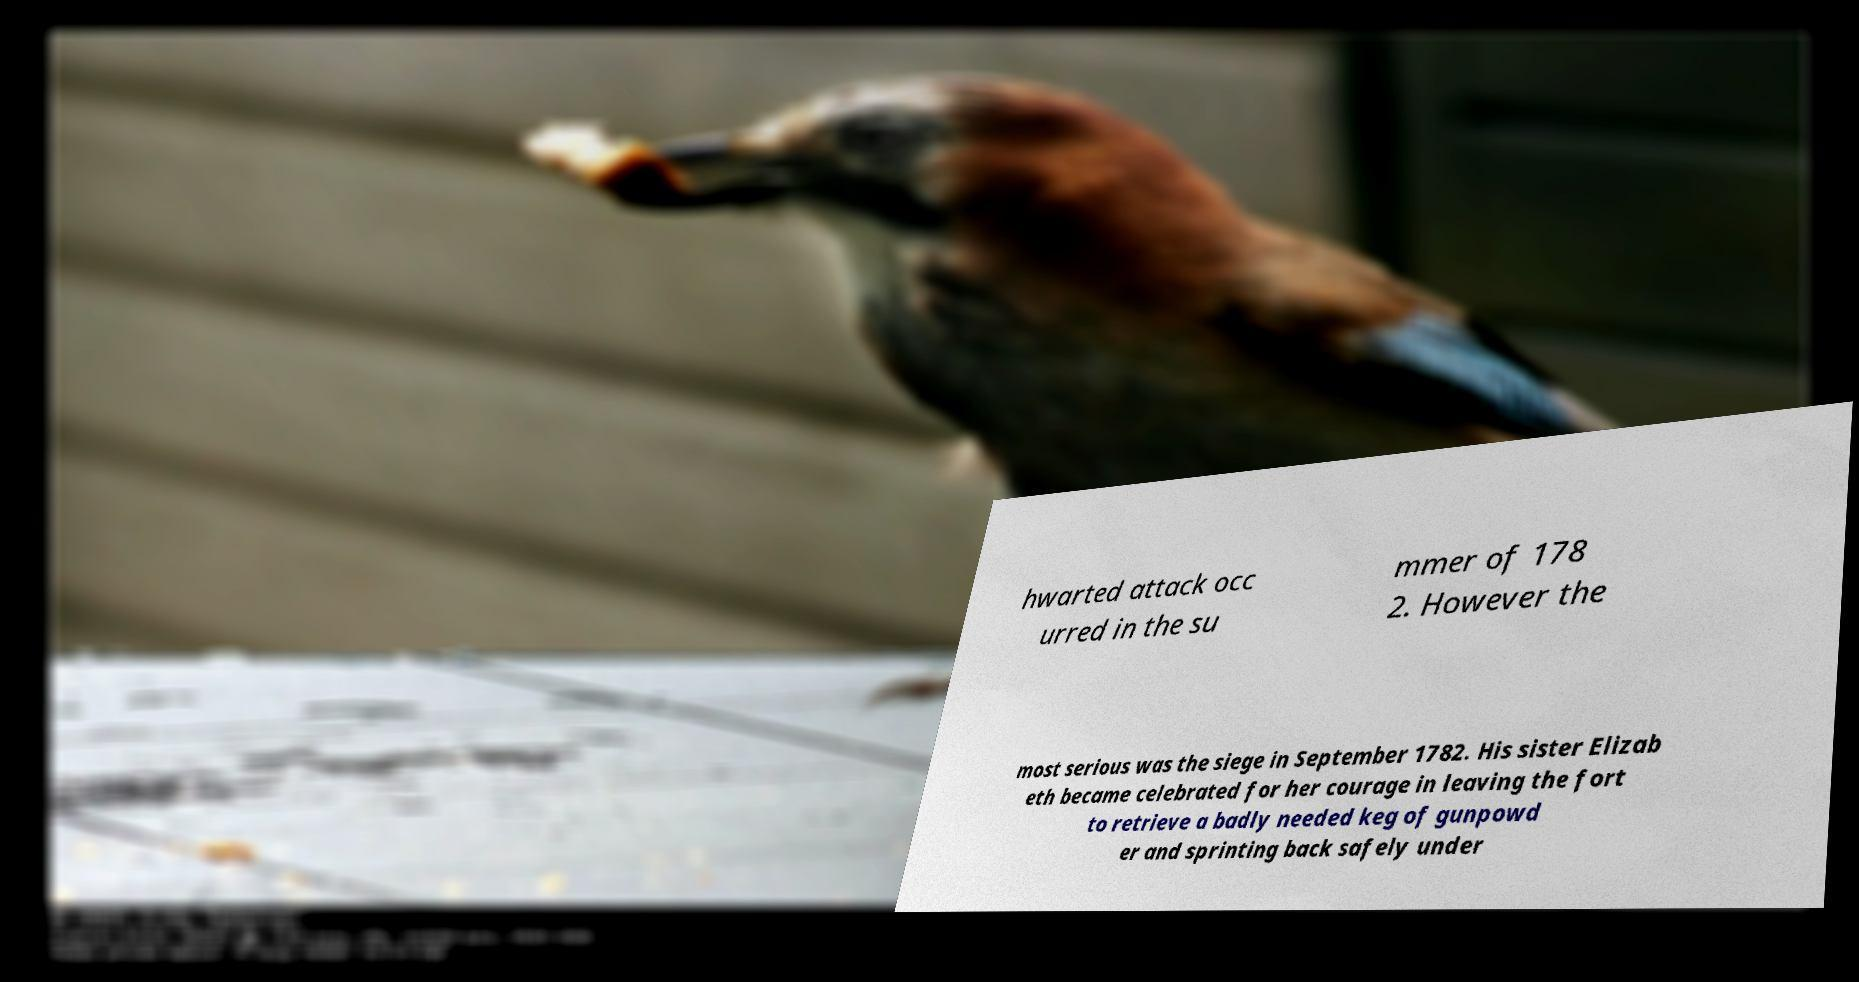Could you assist in decoding the text presented in this image and type it out clearly? hwarted attack occ urred in the su mmer of 178 2. However the most serious was the siege in September 1782. His sister Elizab eth became celebrated for her courage in leaving the fort to retrieve a badly needed keg of gunpowd er and sprinting back safely under 